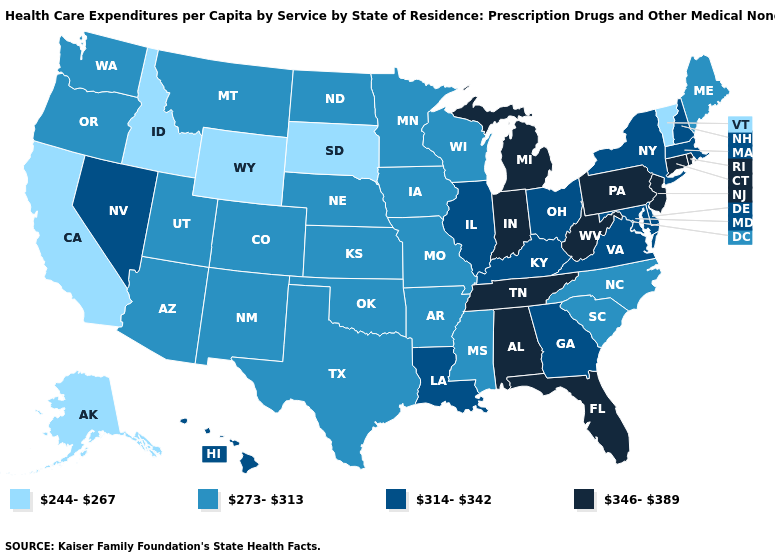Among the states that border Georgia , which have the highest value?
Keep it brief. Alabama, Florida, Tennessee. What is the value of Illinois?
Concise answer only. 314-342. Among the states that border North Carolina , which have the lowest value?
Give a very brief answer. South Carolina. What is the highest value in the USA?
Keep it brief. 346-389. Which states have the lowest value in the Northeast?
Keep it brief. Vermont. Does Mississippi have the lowest value in the USA?
Give a very brief answer. No. Among the states that border Indiana , which have the highest value?
Concise answer only. Michigan. Does Indiana have the highest value in the USA?
Concise answer only. Yes. What is the value of Montana?
Keep it brief. 273-313. Is the legend a continuous bar?
Be succinct. No. Does Kentucky have the same value as New York?
Quick response, please. Yes. Name the states that have a value in the range 273-313?
Quick response, please. Arizona, Arkansas, Colorado, Iowa, Kansas, Maine, Minnesota, Mississippi, Missouri, Montana, Nebraska, New Mexico, North Carolina, North Dakota, Oklahoma, Oregon, South Carolina, Texas, Utah, Washington, Wisconsin. Does Nebraska have the highest value in the MidWest?
Short answer required. No. What is the highest value in the USA?
Concise answer only. 346-389. Does Wyoming have the lowest value in the West?
Write a very short answer. Yes. 